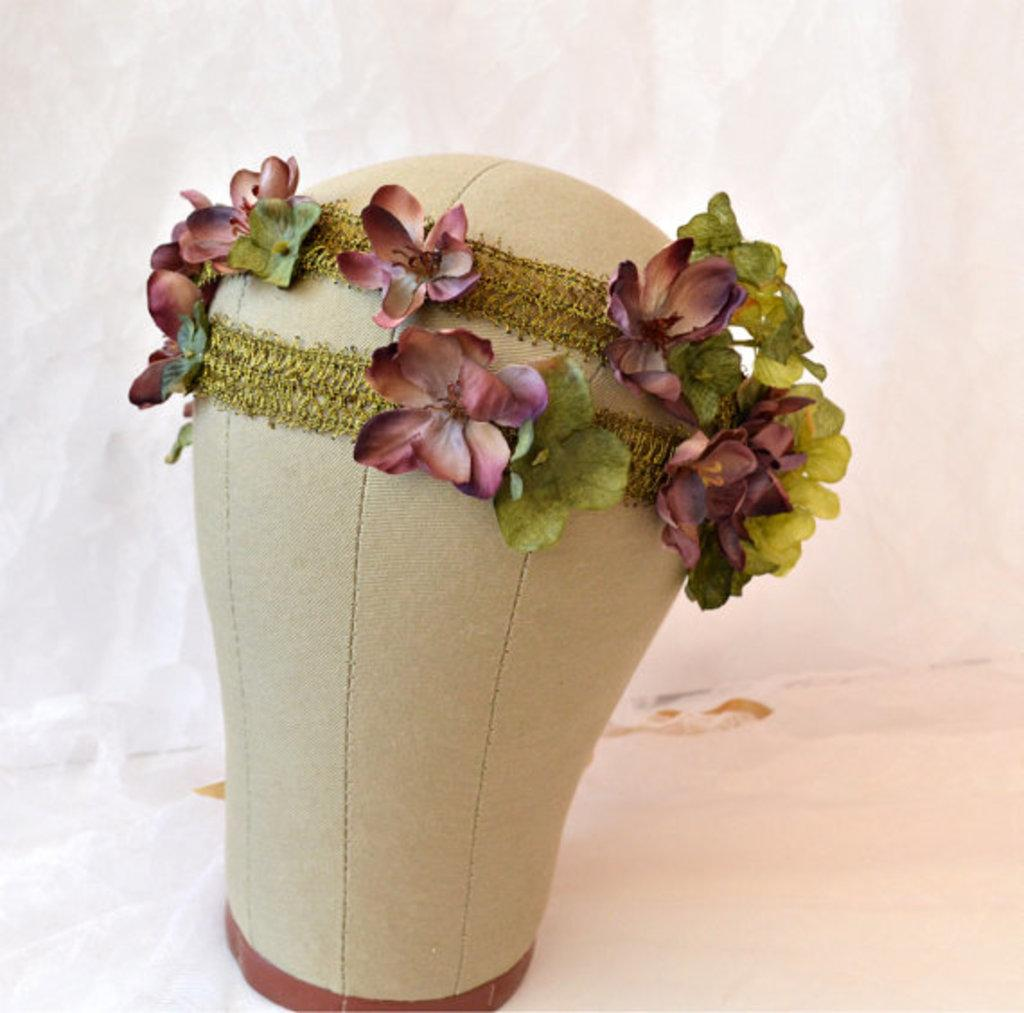What is present on the surface in the image? There is an object on the surface in the image. Can you describe the appearance of the object? The object is decorated with flowers. What type of chain is attached to the foot of the object in the image? There is no chain or foot mentioned in the image; the object is only described as being decorated with flowers. 